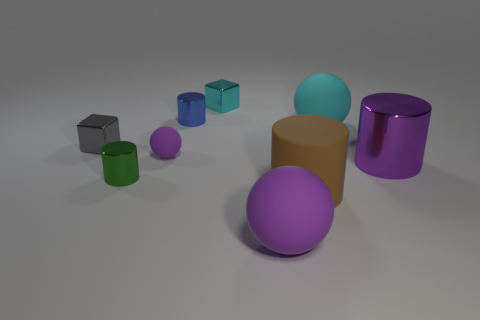How many large spheres have the same material as the big brown cylinder?
Your answer should be compact. 2. Are there the same number of purple balls left of the small rubber ball and cyan matte objects?
Provide a short and direct response. No. What material is the tiny object that is the same color as the large metal cylinder?
Provide a short and direct response. Rubber. Do the gray metal object and the cylinder that is on the right side of the cyan rubber ball have the same size?
Offer a very short reply. No. What number of other objects are there of the same size as the cyan block?
Your answer should be compact. 4. What number of other objects are there of the same color as the small rubber ball?
Give a very brief answer. 2. Is there any other thing that is the same size as the blue thing?
Your answer should be compact. Yes. What number of other objects are there of the same shape as the small green thing?
Keep it short and to the point. 3. Is the brown cylinder the same size as the green metal cylinder?
Give a very brief answer. No. Are there any purple matte things?
Give a very brief answer. Yes. 